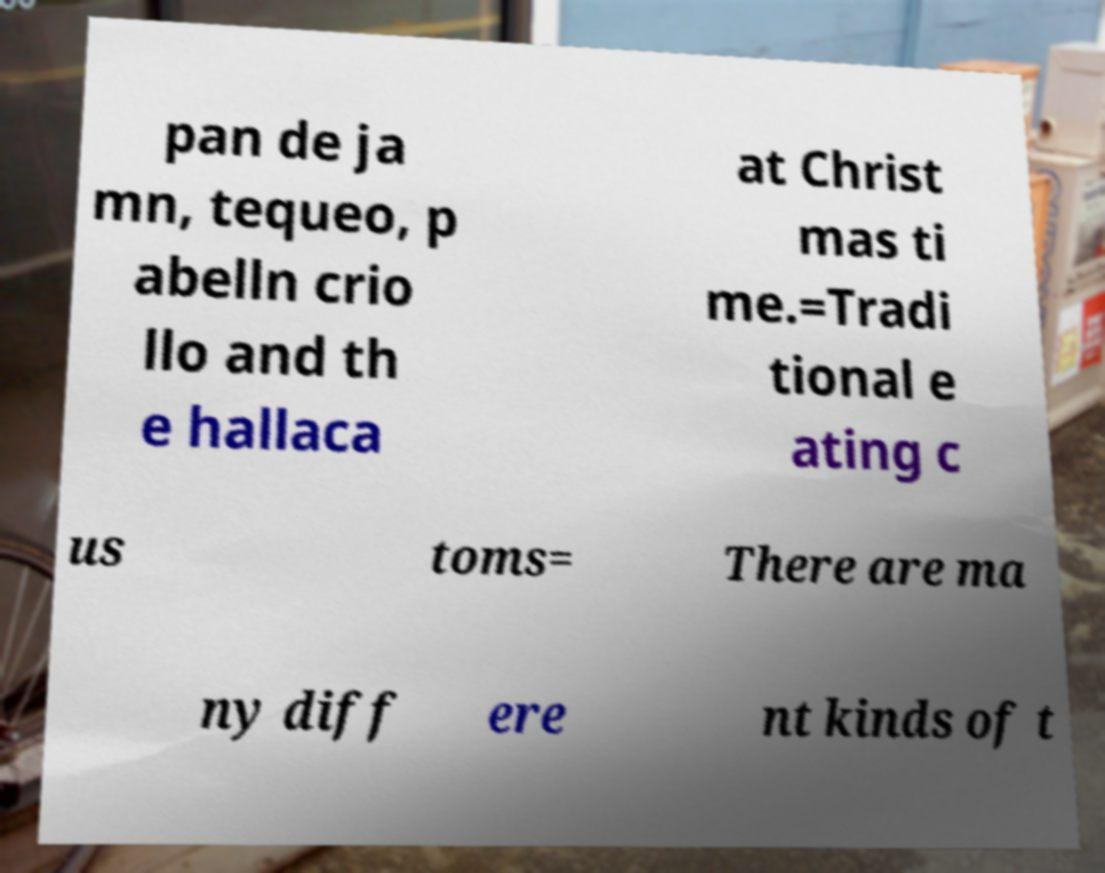Can you accurately transcribe the text from the provided image for me? pan de ja mn, tequeo, p abelln crio llo and th e hallaca at Christ mas ti me.=Tradi tional e ating c us toms= There are ma ny diff ere nt kinds of t 